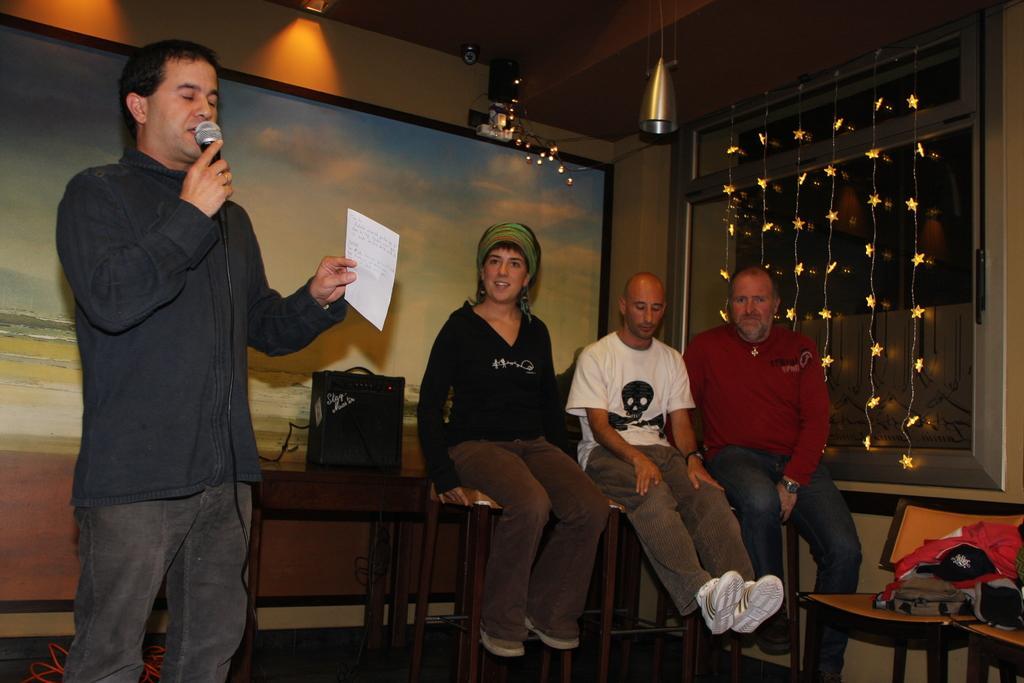In one or two sentences, can you explain what this image depicts? This picture is clicked inside the room. On the right corner we can see there are some objects placed on the top of the tables and we can see the objects hanging on the roof and we can see the group of persons wearing t-shirts and sitting on the tables and at the top we can see the decoration lights and some other objects. On the left we can see a person wearing shirt, holding a microphone and a paper and standing. In the background we can see the picture of a water body and the sky, we can see an object placed on the top of the table and we can see some other objects. 